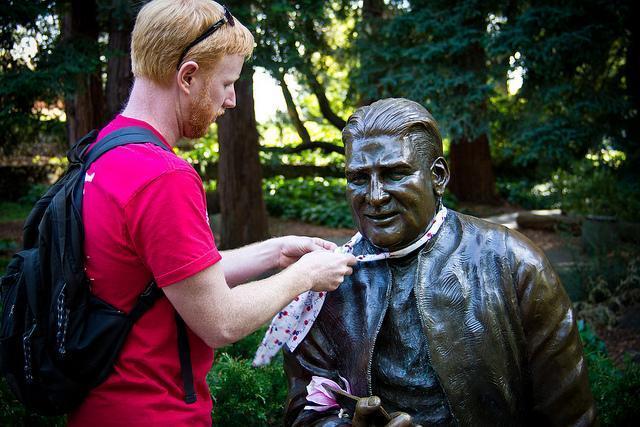How many living people are in this image?
Give a very brief answer. 1. How many train cars are behind the locomotive?
Give a very brief answer. 0. 